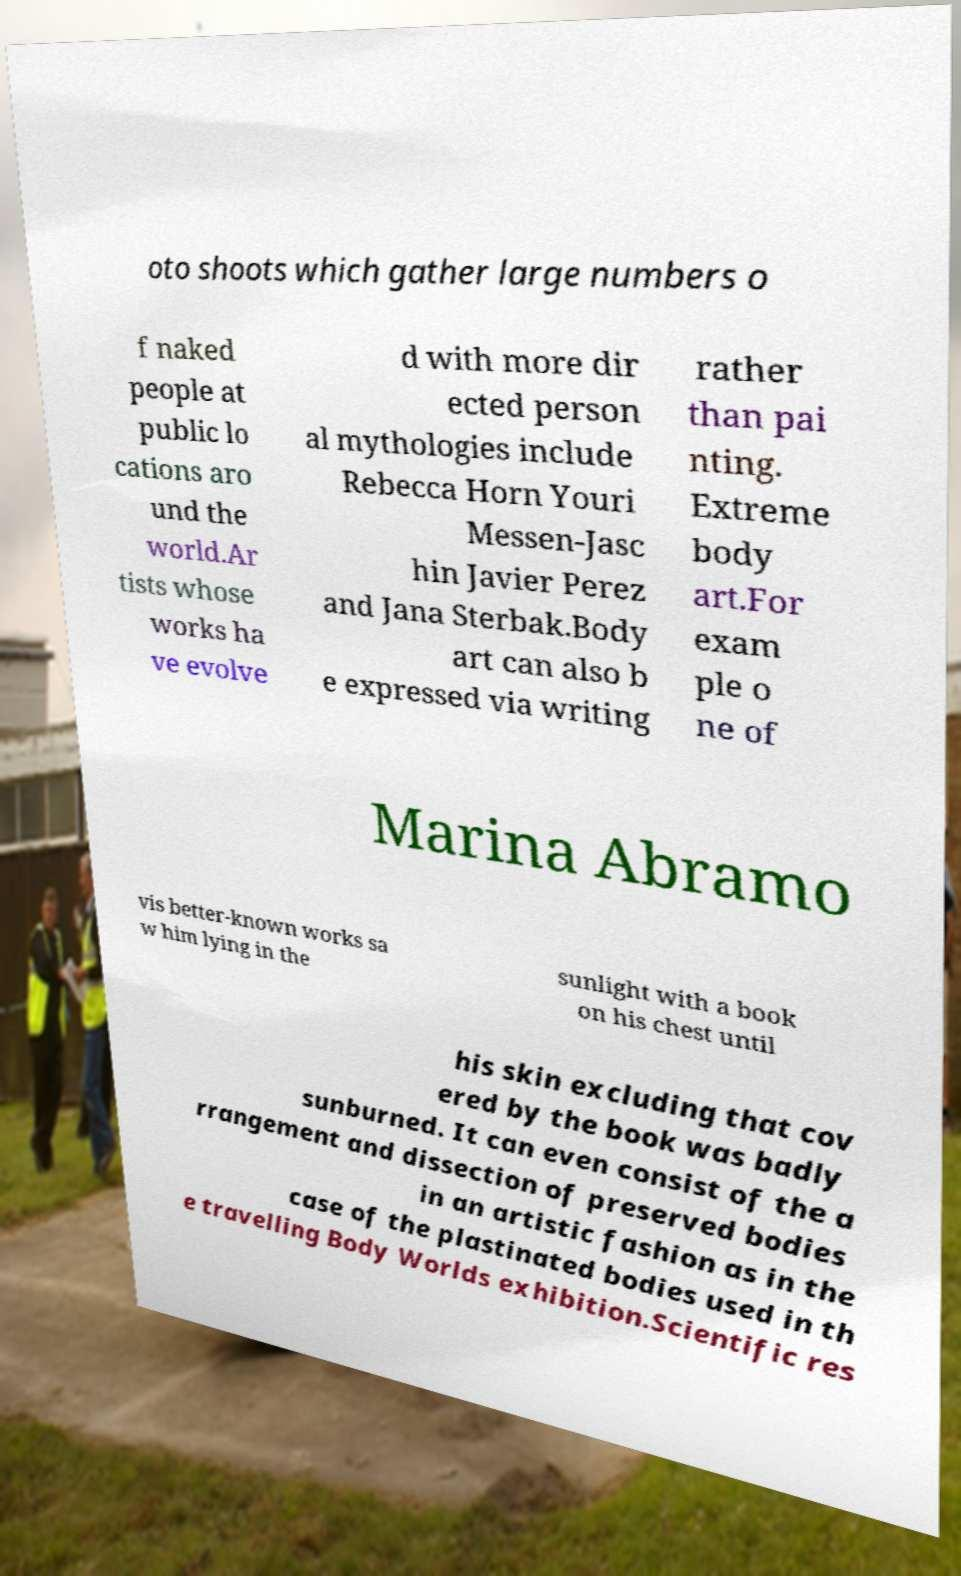There's text embedded in this image that I need extracted. Can you transcribe it verbatim? oto shoots which gather large numbers o f naked people at public lo cations aro und the world.Ar tists whose works ha ve evolve d with more dir ected person al mythologies include Rebecca Horn Youri Messen-Jasc hin Javier Perez and Jana Sterbak.Body art can also b e expressed via writing rather than pai nting. Extreme body art.For exam ple o ne of Marina Abramo vis better-known works sa w him lying in the sunlight with a book on his chest until his skin excluding that cov ered by the book was badly sunburned. It can even consist of the a rrangement and dissection of preserved bodies in an artistic fashion as in the case of the plastinated bodies used in th e travelling Body Worlds exhibition.Scientific res 